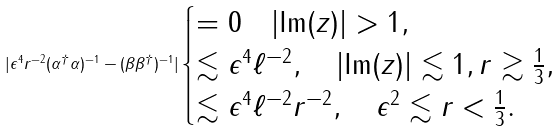<formula> <loc_0><loc_0><loc_500><loc_500>| \epsilon ^ { 4 } r ^ { - 2 } ( \alpha ^ { \dag } \alpha ) ^ { - 1 } - ( \beta \beta ^ { \dag } ) ^ { - 1 } | \begin{cases} = 0 \quad | \text {Im} ( z ) | > 1 , \\ \lesssim \epsilon ^ { 4 } \ell ^ { - 2 } , \quad | \text {Im} ( z ) | \lesssim 1 , r \gtrsim \frac { 1 } { 3 } , \\ \lesssim \epsilon ^ { 4 } \ell ^ { - 2 } r ^ { - 2 } , \quad \epsilon ^ { 2 } \lesssim r < \frac { 1 } { 3 } . \end{cases}</formula> 